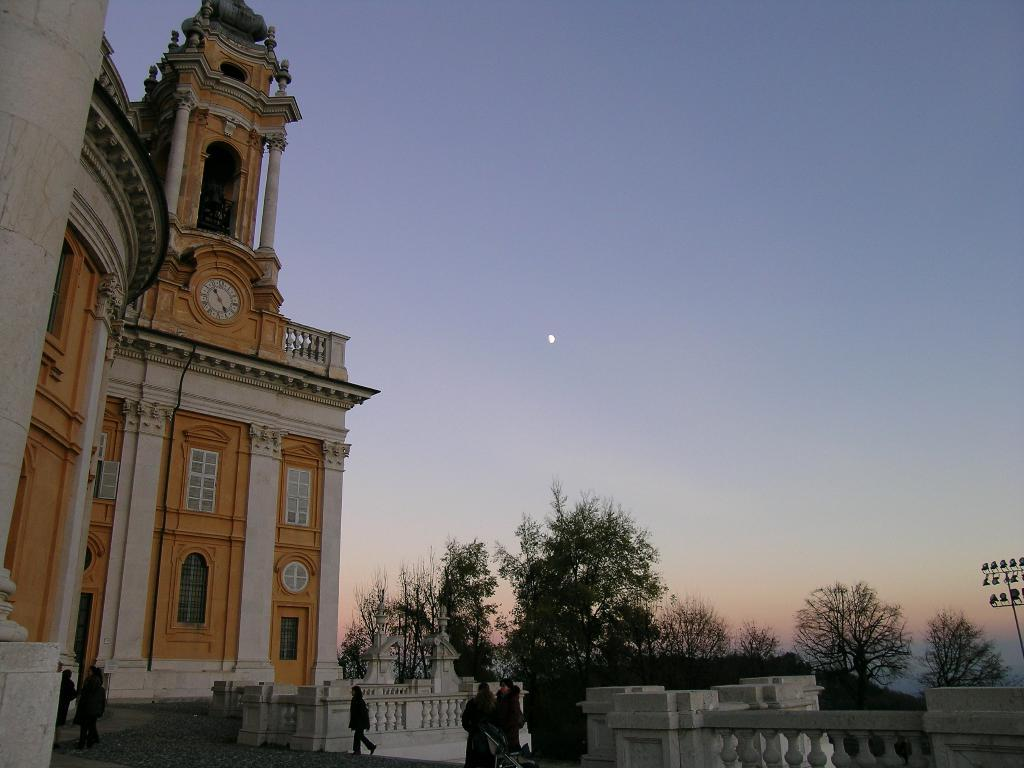Who or what can be seen in the image? There are people in the image. What type of structure is present in the image? There is a building in the image. What is a feature of the building? A clock is visible in the building. What type of vegetation is present in the image? There are trees in the image. What can be seen on the right side of the image? There are lights on the right side of the image. Can you tell me what your aunt is doing in the image? There is no mention of an aunt in the image, so we cannot answer that question. 